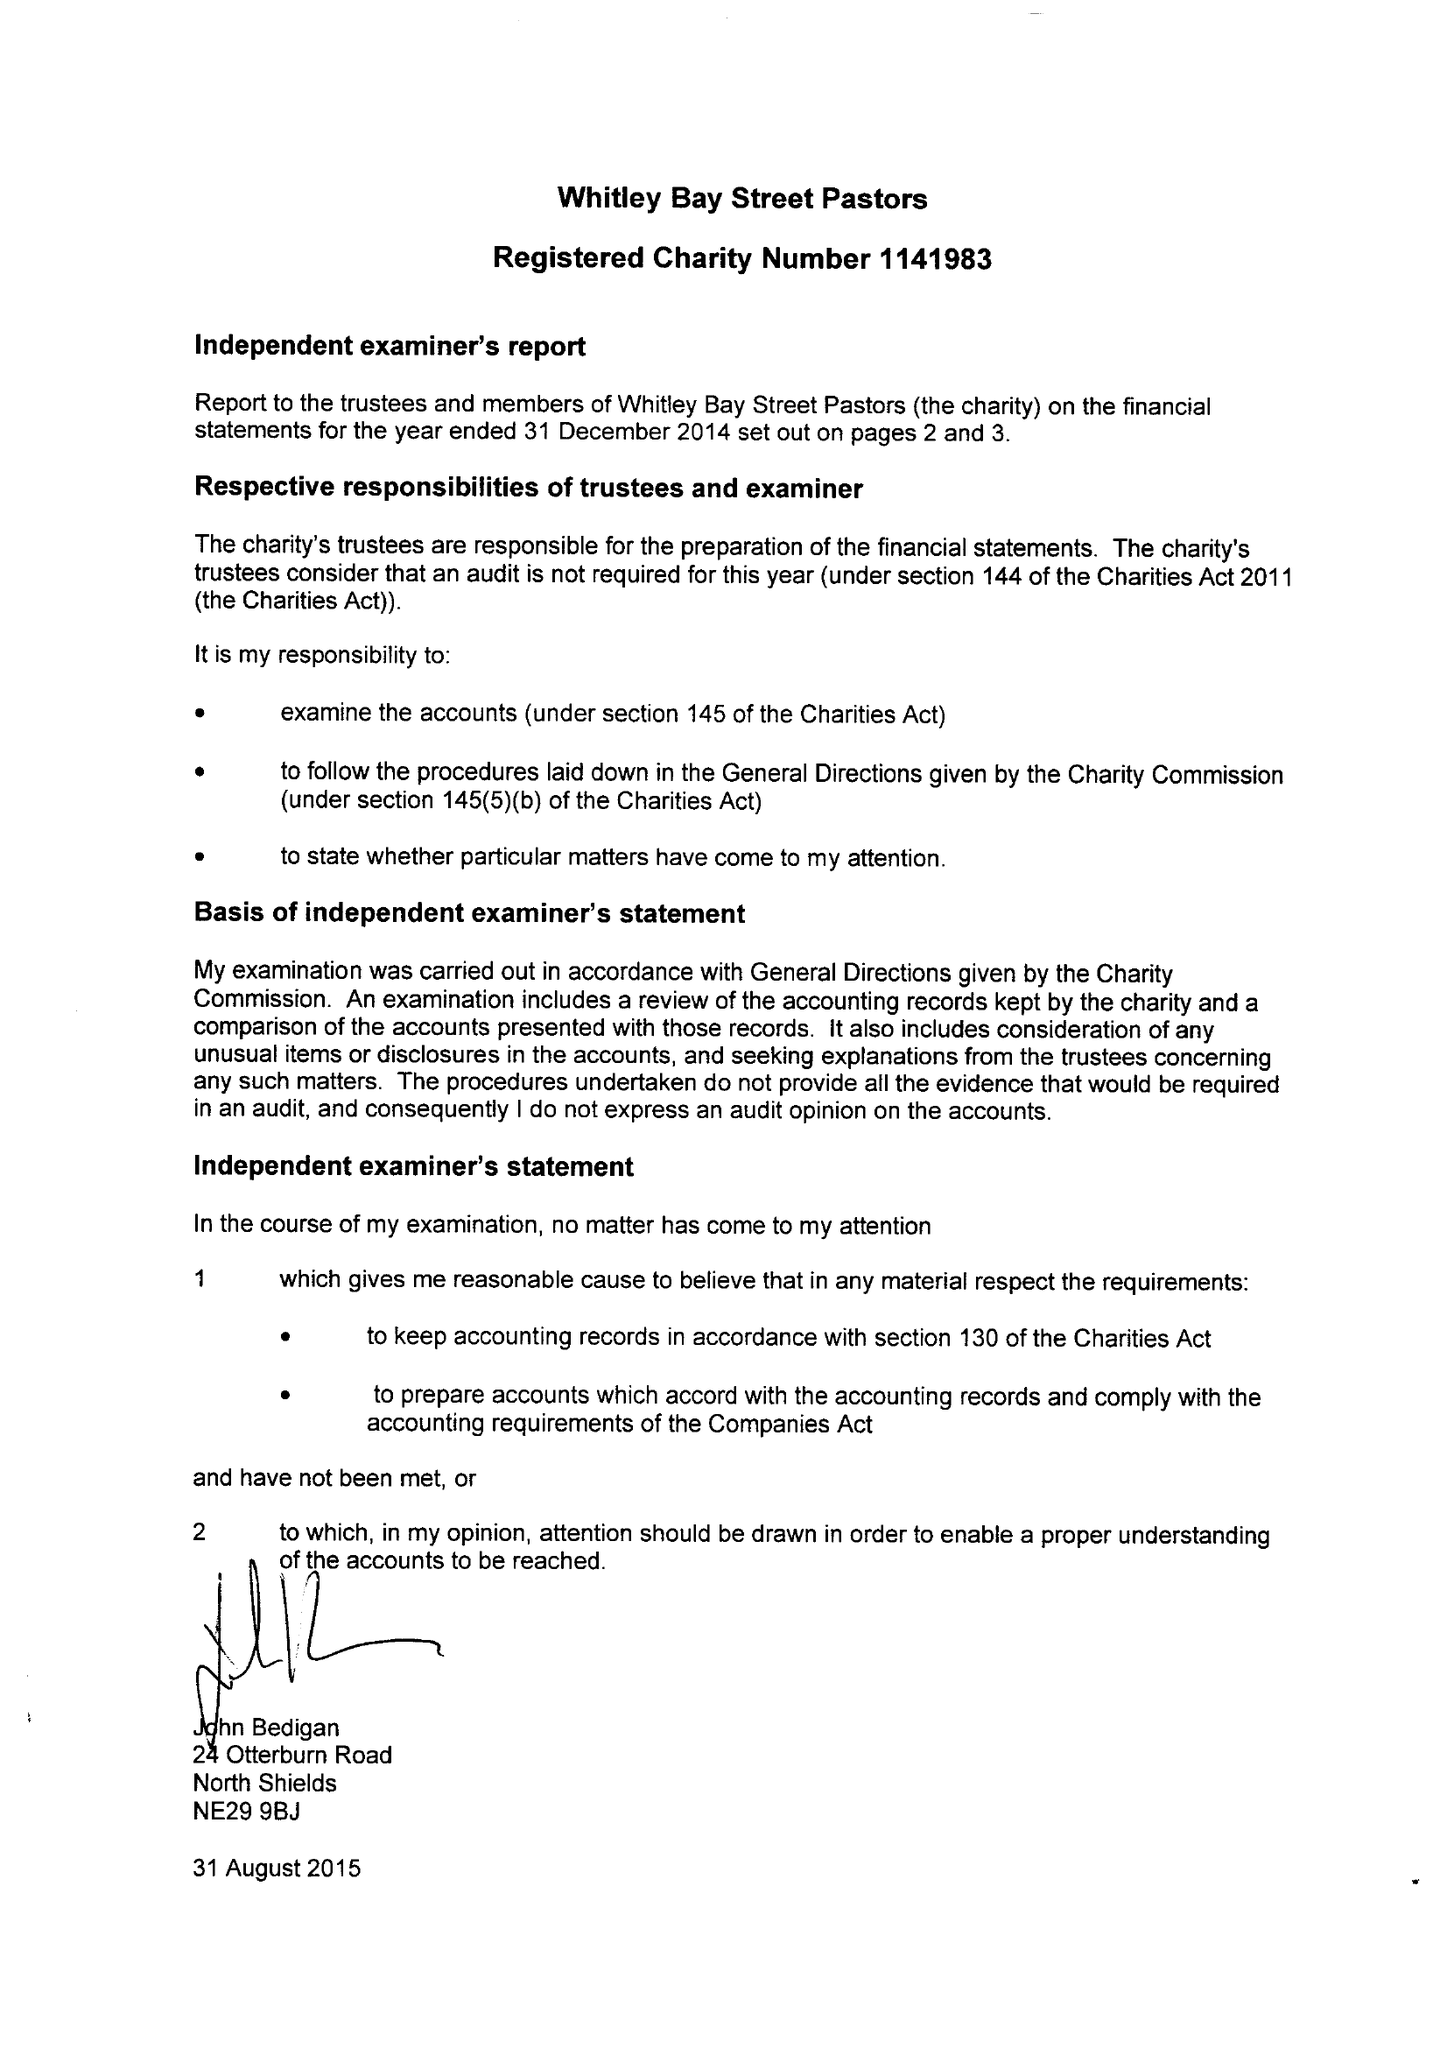What is the value for the address__postcode?
Answer the question using a single word or phrase. NE26 2ET 